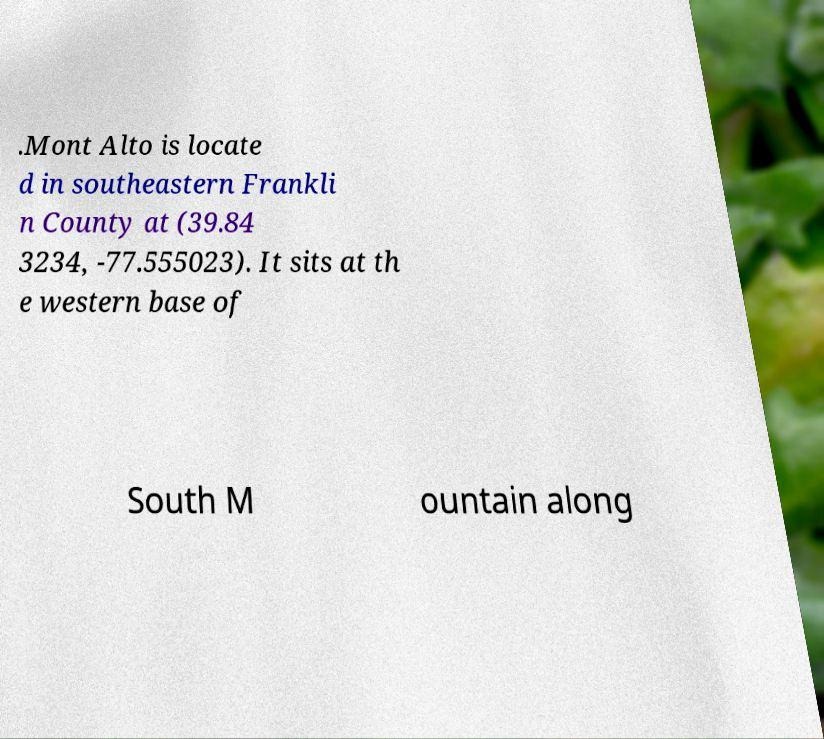Could you extract and type out the text from this image? .Mont Alto is locate d in southeastern Frankli n County at (39.84 3234, -77.555023). It sits at th e western base of South M ountain along 